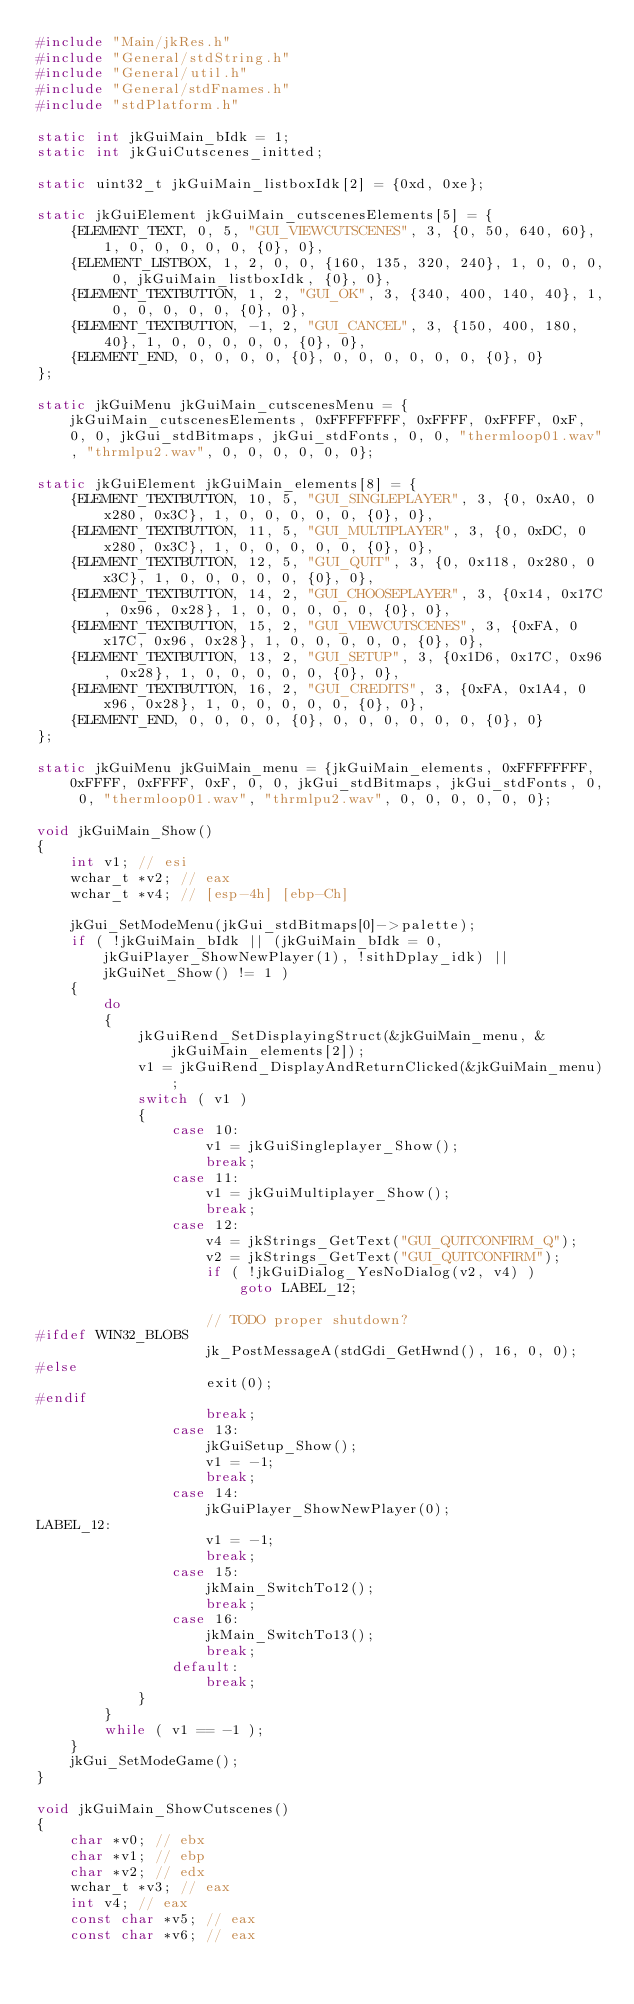Convert code to text. <code><loc_0><loc_0><loc_500><loc_500><_C_>#include "Main/jkRes.h"
#include "General/stdString.h"
#include "General/util.h"
#include "General/stdFnames.h"
#include "stdPlatform.h"

static int jkGuiMain_bIdk = 1;
static int jkGuiCutscenes_initted;

static uint32_t jkGuiMain_listboxIdk[2] = {0xd, 0xe};

static jkGuiElement jkGuiMain_cutscenesElements[5] = {
    {ELEMENT_TEXT, 0, 5, "GUI_VIEWCUTSCENES", 3, {0, 50, 640, 60}, 1, 0, 0, 0, 0, 0, {0}, 0},
    {ELEMENT_LISTBOX, 1, 2, 0, 0, {160, 135, 320, 240}, 1, 0, 0, 0, 0, jkGuiMain_listboxIdk, {0}, 0},
    {ELEMENT_TEXTBUTTON, 1, 2, "GUI_OK", 3, {340, 400, 140, 40}, 1, 0, 0, 0, 0, 0, {0}, 0},
    {ELEMENT_TEXTBUTTON, -1, 2, "GUI_CANCEL", 3, {150, 400, 180, 40}, 1, 0, 0, 0, 0, 0, {0}, 0},
    {ELEMENT_END, 0, 0, 0, 0, {0}, 0, 0, 0, 0, 0, 0, {0}, 0}
};

static jkGuiMenu jkGuiMain_cutscenesMenu = {jkGuiMain_cutscenesElements, 0xFFFFFFFF, 0xFFFF, 0xFFFF, 0xF, 0, 0, jkGui_stdBitmaps, jkGui_stdFonts, 0, 0, "thermloop01.wav", "thrmlpu2.wav", 0, 0, 0, 0, 0, 0};

static jkGuiElement jkGuiMain_elements[8] = {
    {ELEMENT_TEXTBUTTON, 10, 5, "GUI_SINGLEPLAYER", 3, {0, 0xA0, 0x280, 0x3C}, 1, 0, 0, 0, 0, 0, {0}, 0},
    {ELEMENT_TEXTBUTTON, 11, 5, "GUI_MULTIPLAYER", 3, {0, 0xDC, 0x280, 0x3C}, 1, 0, 0, 0, 0, 0, {0}, 0},
    {ELEMENT_TEXTBUTTON, 12, 5, "GUI_QUIT", 3, {0, 0x118, 0x280, 0x3C}, 1, 0, 0, 0, 0, 0, {0}, 0},
    {ELEMENT_TEXTBUTTON, 14, 2, "GUI_CHOOSEPLAYER", 3, {0x14, 0x17C, 0x96, 0x28}, 1, 0, 0, 0, 0, 0, {0}, 0},
    {ELEMENT_TEXTBUTTON, 15, 2, "GUI_VIEWCUTSCENES", 3, {0xFA, 0x17C, 0x96, 0x28}, 1, 0, 0, 0, 0, 0, {0}, 0},
    {ELEMENT_TEXTBUTTON, 13, 2, "GUI_SETUP", 3, {0x1D6, 0x17C, 0x96, 0x28}, 1, 0, 0, 0, 0, 0, {0}, 0},
    {ELEMENT_TEXTBUTTON, 16, 2, "GUI_CREDITS", 3, {0xFA, 0x1A4, 0x96, 0x28}, 1, 0, 0, 0, 0, 0, {0}, 0},
    {ELEMENT_END, 0, 0, 0, 0, {0}, 0, 0, 0, 0, 0, 0, {0}, 0}
};

static jkGuiMenu jkGuiMain_menu = {jkGuiMain_elements, 0xFFFFFFFF, 0xFFFF, 0xFFFF, 0xF, 0, 0, jkGui_stdBitmaps, jkGui_stdFonts, 0, 0, "thermloop01.wav", "thrmlpu2.wav", 0, 0, 0, 0, 0, 0};

void jkGuiMain_Show()
{
    int v1; // esi
    wchar_t *v2; // eax
    wchar_t *v4; // [esp-4h] [ebp-Ch]

    jkGui_SetModeMenu(jkGui_stdBitmaps[0]->palette);
    if ( !jkGuiMain_bIdk || (jkGuiMain_bIdk = 0, jkGuiPlayer_ShowNewPlayer(1), !sithDplay_idk) || jkGuiNet_Show() != 1 )
    {
        do
        {
            jkGuiRend_SetDisplayingStruct(&jkGuiMain_menu, &jkGuiMain_elements[2]);
            v1 = jkGuiRend_DisplayAndReturnClicked(&jkGuiMain_menu);
            switch ( v1 )
            {
                case 10:
                    v1 = jkGuiSingleplayer_Show();
                    break;
                case 11:
                    v1 = jkGuiMultiplayer_Show();
                    break;
                case 12:
                    v4 = jkStrings_GetText("GUI_QUITCONFIRM_Q");
                    v2 = jkStrings_GetText("GUI_QUITCONFIRM");
                    if ( !jkGuiDialog_YesNoDialog(v2, v4) )
                        goto LABEL_12;

                    // TODO proper shutdown?
#ifdef WIN32_BLOBS
                    jk_PostMessageA(stdGdi_GetHwnd(), 16, 0, 0);
#else
                    exit(0);
#endif
                    break;
                case 13:
                    jkGuiSetup_Show();
                    v1 = -1;
                    break;
                case 14:
                    jkGuiPlayer_ShowNewPlayer(0);
LABEL_12:
                    v1 = -1;
                    break;
                case 15:
                    jkMain_SwitchTo12();
                    break;
                case 16:
                    jkMain_SwitchTo13();
                    break;
                default:
                    break;
            }
        }
        while ( v1 == -1 );
    }
    jkGui_SetModeGame();
}

void jkGuiMain_ShowCutscenes()
{
    char *v0; // ebx
    char *v1; // ebp
    char *v2; // edx
    wchar_t *v3; // eax
    int v4; // eax
    const char *v5; // eax
    const char *v6; // eax</code> 